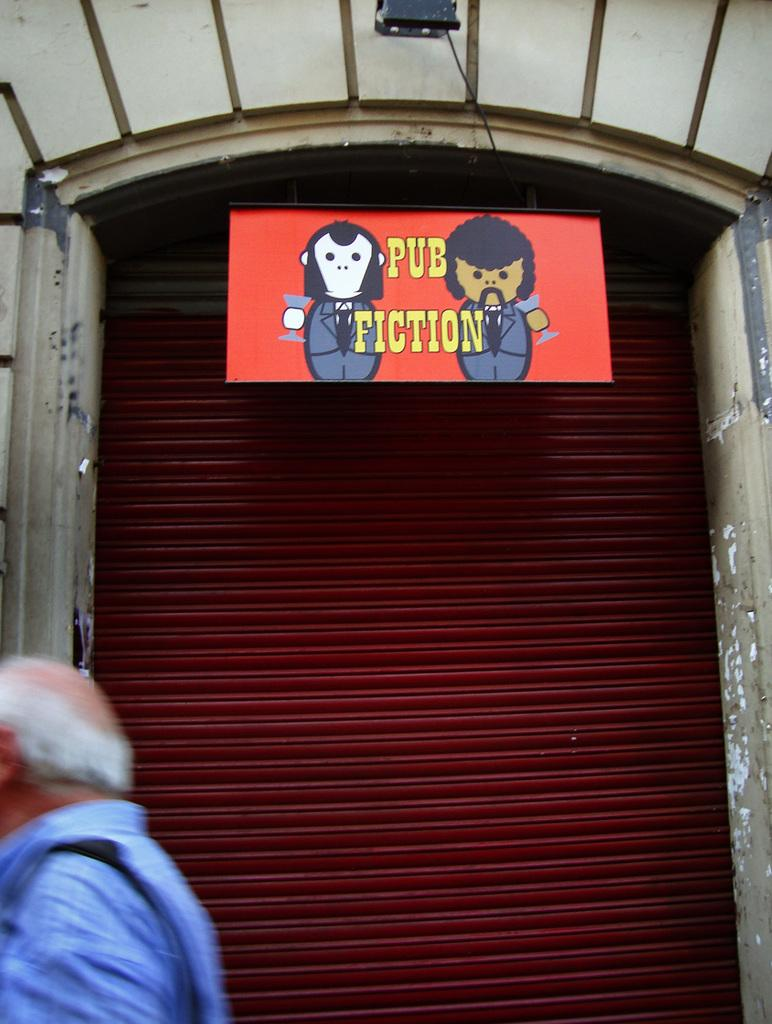Who is present in the image? There is a person in the image. What is the person wearing? The person is wearing a blue shirt. Where is the person located in the image? The person is located on the left side of the image. What can be seen in the background of the image? There is a shutter and a board hanging above the shutter in the background of the image. What type of beef is being served at the event in the image? There is no event or beef present in the image; it features a person wearing a blue shirt on the left side of the image with a shutter and a board hanging above it in the background. 